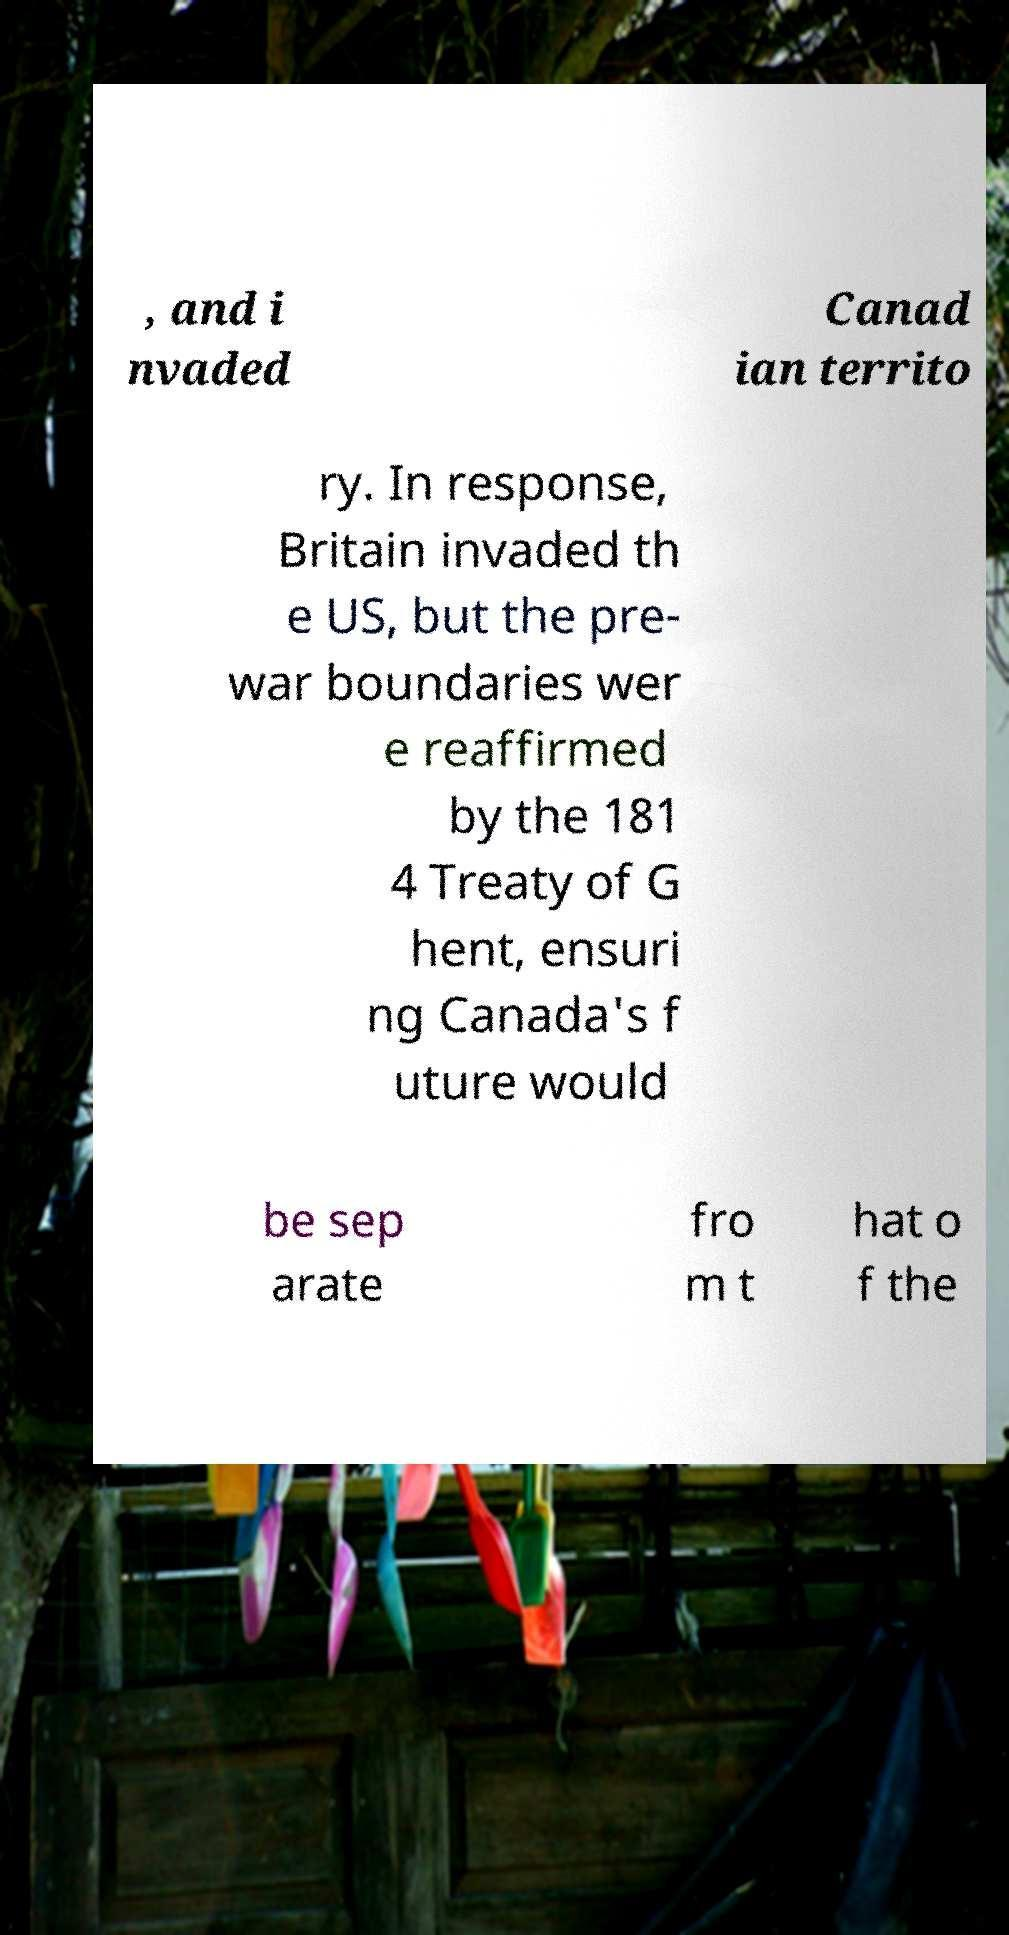For documentation purposes, I need the text within this image transcribed. Could you provide that? , and i nvaded Canad ian territo ry. In response, Britain invaded th e US, but the pre- war boundaries wer e reaffirmed by the 181 4 Treaty of G hent, ensuri ng Canada's f uture would be sep arate fro m t hat o f the 